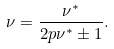Convert formula to latex. <formula><loc_0><loc_0><loc_500><loc_500>\nu = { \frac { \nu ^ { * } } { 2 p \nu ^ { * } \pm 1 } } .</formula> 